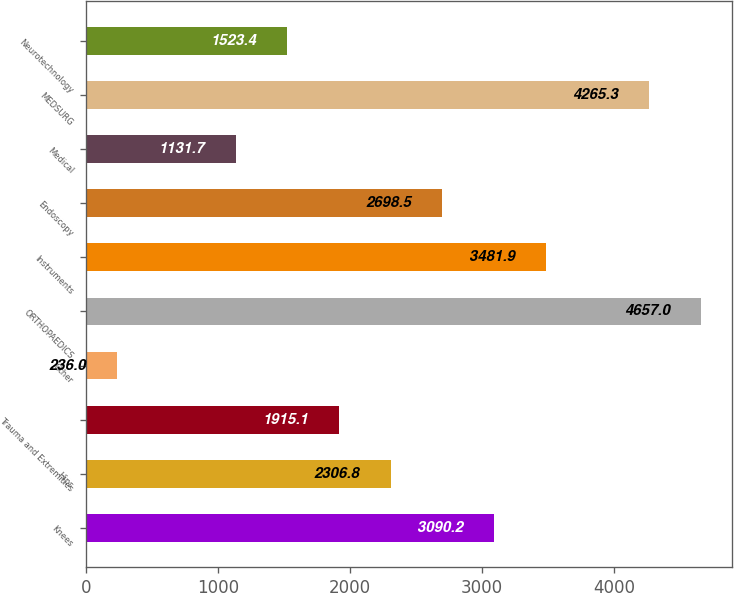Convert chart. <chart><loc_0><loc_0><loc_500><loc_500><bar_chart><fcel>Knees<fcel>Hips<fcel>Trauma and Extremities<fcel>Other<fcel>ORTHOPAEDICS<fcel>Instruments<fcel>Endoscopy<fcel>Medical<fcel>MEDSURG<fcel>Neurotechnology<nl><fcel>3090.2<fcel>2306.8<fcel>1915.1<fcel>236<fcel>4657<fcel>3481.9<fcel>2698.5<fcel>1131.7<fcel>4265.3<fcel>1523.4<nl></chart> 